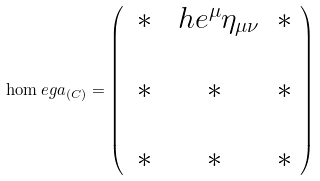Convert formula to latex. <formula><loc_0><loc_0><loc_500><loc_500>\hom e g a _ { ( C ) } = \left ( \begin{array} { c c c } \, * & \ h e ^ { \mu } \eta _ { \mu \nu } & * \\ & & \\ \, * & * & * \\ & & \\ \, * & * & * \end{array} \right )</formula> 